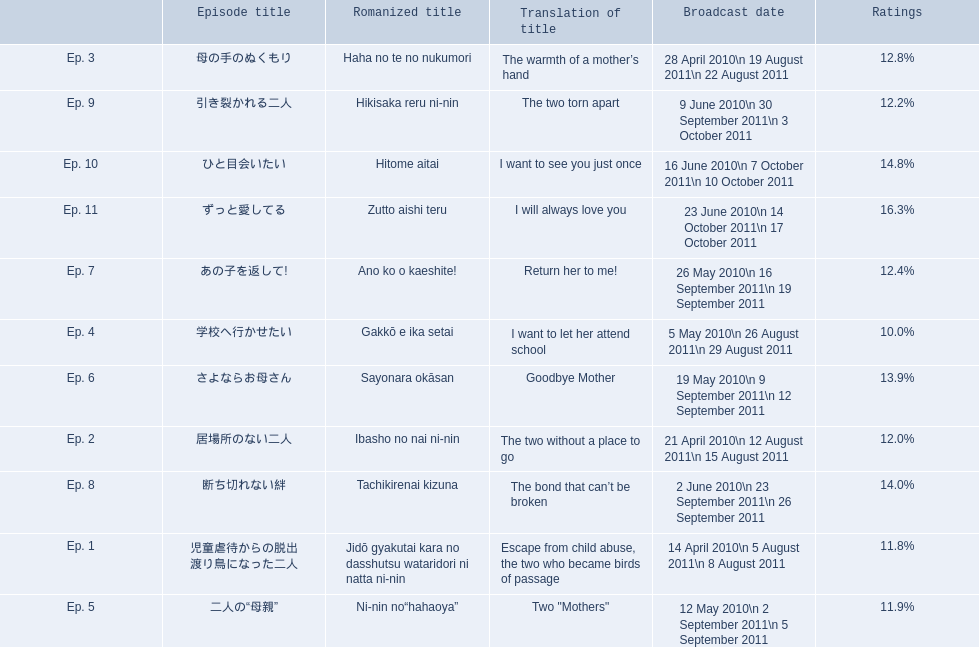What were the episode titles of mother? 児童虐待からの脱出 渡り鳥になった二人, 居場所のない二人, 母の手のぬくもり, 学校へ行かせたい, 二人の“母親”, さよならお母さん, あの子を返して!, 断ち切れない絆, 引き裂かれる二人, ひと目会いたい, ずっと愛してる. Which of these episodes had the highest ratings? ずっと愛してる. 